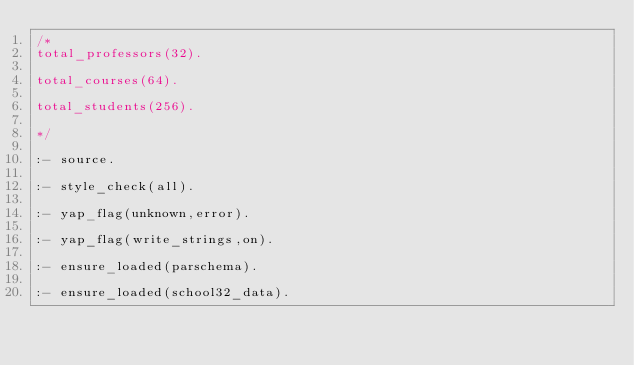<code> <loc_0><loc_0><loc_500><loc_500><_Prolog_>/*
total_professors(32).

total_courses(64).

total_students(256).

*/

:- source.

:- style_check(all).

:- yap_flag(unknown,error).

:- yap_flag(write_strings,on).

:- ensure_loaded(parschema).

:- ensure_loaded(school32_data).

</code> 